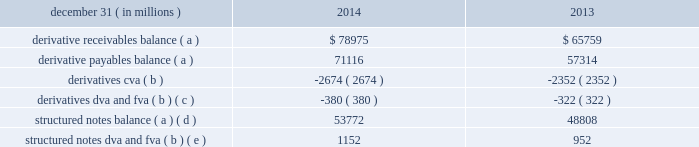Notes to consolidated financial statements 196 jpmorgan chase & co./2014 annual report credit and funding adjustments when determining the fair value of an instrument , it may be necessary to record adjustments to the firm 2019s estimates of fair value in order to reflect counterparty credit quality , the firm 2019s own creditworthiness , and the impact of funding : 2022 credit valuation adjustments ( 201ccva 201d ) are taken to reflect the credit quality of a counterparty in the valuation of derivatives .
Cva are necessary when the market price ( or parameter ) is not indicative of the credit quality of the counterparty .
As few classes of derivative contracts are listed on an exchange , derivative positions are predominantly valued using models that use as their basis observable market parameters .
An adjustment therefore may be necessary to reflect the credit quality of each derivative counterparty to arrive at fair value .
The firm estimates derivatives cva using a scenario analysis to estimate the expected credit exposure across all of the firm 2019s positions with each counterparty , and then estimates losses as a result of a counterparty credit event .
The key inputs to this methodology are ( i ) the expected positive exposure to each counterparty based on a simulation that assumes the current population of existing derivatives with each counterparty remains unchanged and considers contractual factors designed to mitigate the firm 2019s credit exposure , such as collateral and legal rights of offset ; ( ii ) the probability of a default event occurring for each counterparty , as derived from observed or estimated cds spreads ; and ( iii ) estimated recovery rates implied by cds , adjusted to consider the differences in recovery rates as a derivative creditor relative to those reflected in cds spreads , which generally reflect senior unsecured creditor risk .
As such , the firm estimates derivatives cva relative to the relevant benchmark interest rate .
2022 dva is taken to reflect the credit quality of the firm in the valuation of liabilities measured at fair value .
The dva calculation methodology is generally consistent with the cva methodology described above and incorporates jpmorgan chase 2019s credit spread as observed through the cds market to estimate the probability of default and loss given default as a result of a systemic event affecting the firm .
Structured notes dva is estimated using the current fair value of the structured note as the exposure amount , and is otherwise consistent with the derivative dva methodology .
2022 the firm incorporates the impact of funding in its valuation estimates where there is evidence that a market participant in the principal market would incorporate it in a transfer of the instrument .
As a result , the fair value of collateralized derivatives is estimated by discounting expected future cash flows at the relevant overnight indexed swap ( 201cois 201d ) rate given the underlying collateral agreement with the counterparty .
Effective in 2013 , the firm implemented a fva framework to incorporate the impact of funding into its valuation estimates for uncollateralized ( including partially collateralized ) over- the-counter ( 201cotc 201d ) derivatives and structured notes .
The firm 2019s fva framework leverages its existing cva and dva calculation methodologies , and considers the fact that the firm 2019s own credit risk is a significant component of funding costs .
The key inputs are : ( i ) the expected funding requirements arising from the firm 2019s positions with each counterparty and collateral arrangements ; ( ii ) for assets , the estimated market funding cost in the principal market ; and ( iii ) for liabilities , the hypothetical market funding cost for a transfer to a market participant with a similar credit standing as the firm .
Upon the implementation of the fva framework in 2013 , the firm recorded a one time $ 1.5 billion loss in principal transactions revenue that was recorded in the cib .
While the fva framework applies to both assets and liabilities , the loss on implementation largely related to uncollateralized derivative receivables given that the impact of the firm 2019s own credit risk , which is a significant component of funding costs , was already incorporated in the valuation of liabilities through the application of dva .
The table provides the credit and funding adjustments , excluding the effect of any associated hedging activities , reflected within the consolidated balance sheets as of the dates indicated. .
Derivative receivables balance ( a ) $ 78975 $ 65759 derivative payables balance ( a ) 71116 57314 derivatives cva ( b ) ( 2674 ) ( 2352 ) derivatives dva and fva ( b ) ( c ) ( 380 ) ( 322 ) structured notes balance ( a ) ( d ) 53772 48808 structured notes dva and fva ( b ) ( e ) 1152 952 ( a ) balances are presented net of applicable cva and dva/fva .
( b ) positive cva and dva/fva represent amounts that increased receivable balances or decreased payable balances ; negative cva and dva/fva represent amounts that decreased receivable balances or increased payable balances .
( c ) at december 31 , 2014 and 2013 , included derivatives dva of $ 714 million and $ 715 million , respectively .
( d ) structured notes are predominantly financial instruments containing embedded derivatives that are measured at fair value based on the firm 2019s election under the fair value option .
At december 31 , 2014 and 2013 , included $ 943 million and $ 1.1 billion , respectively , of financial instruments with no embedded derivative for which the fair value option has also been elected .
For further information on these elections , see note 4 .
( e ) at december 31 , 2014 and 2013 , included structured notes dva of $ 1.4 billion and $ 1.4 billion , respectively. .
At december 31 , 2014 what was the structured notes fva balance in billions? 
Computations: ((1152 / 1000) - 1.4)
Answer: -0.248. 